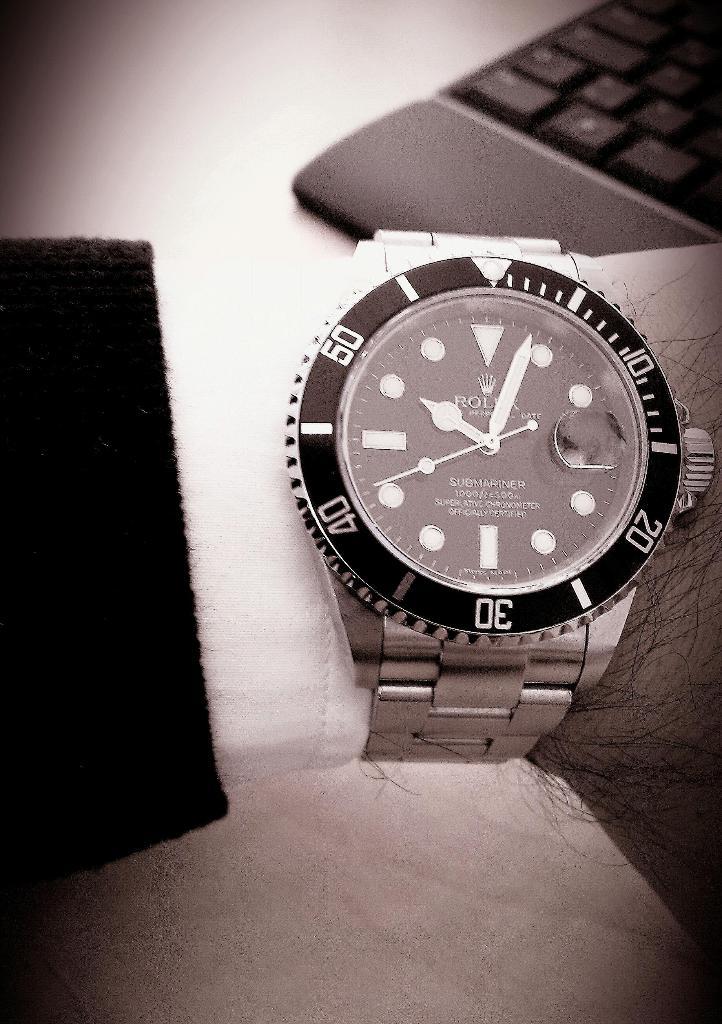Which digits are witten on the face of the watch in silver?
Give a very brief answer. 10, 20, 30, 40, 50. Whats the time?
Your response must be concise. 10:03. 